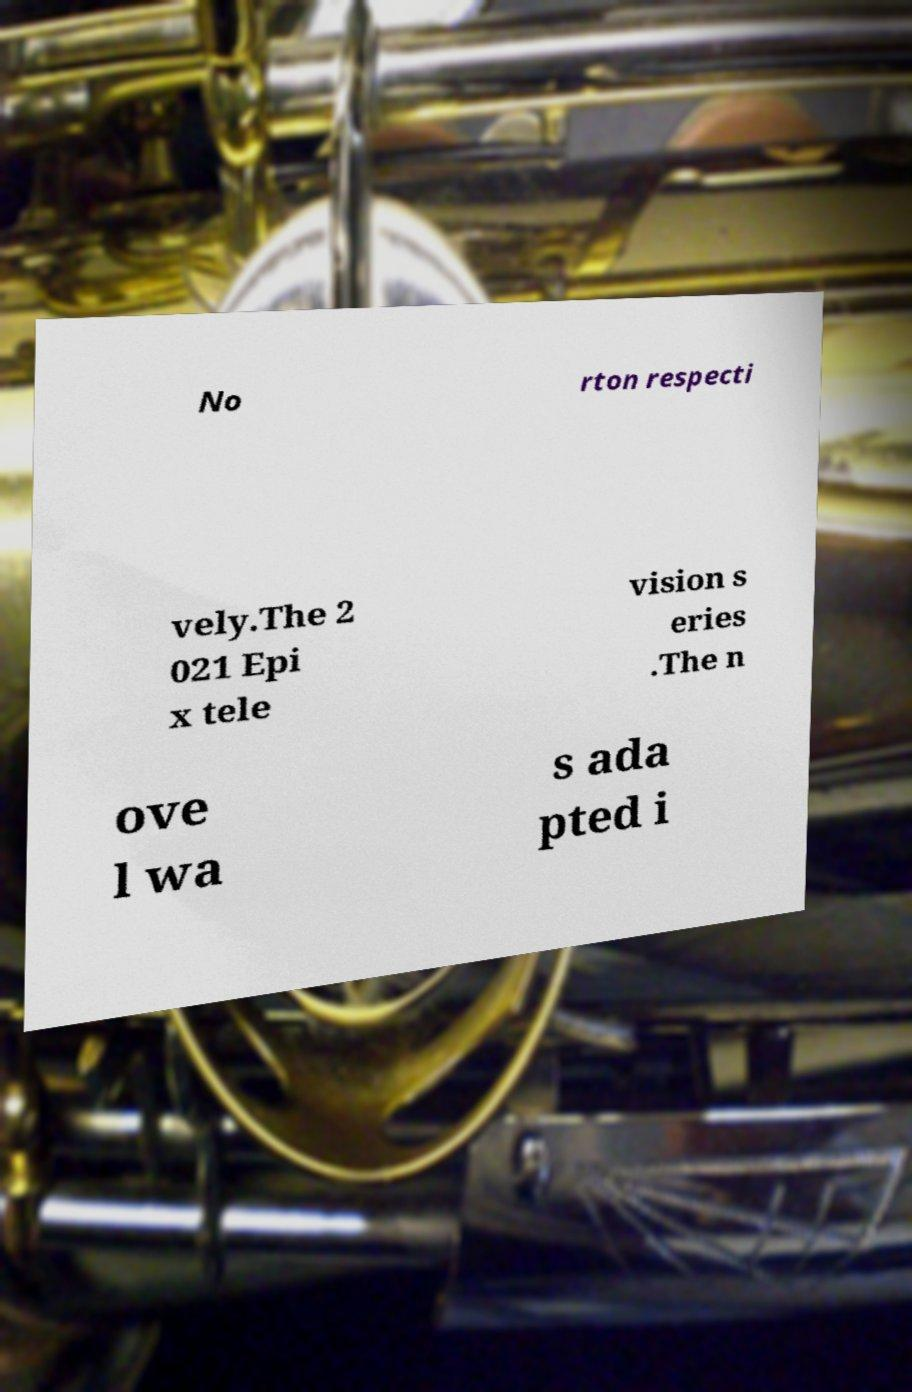Could you extract and type out the text from this image? No rton respecti vely.The 2 021 Epi x tele vision s eries .The n ove l wa s ada pted i 